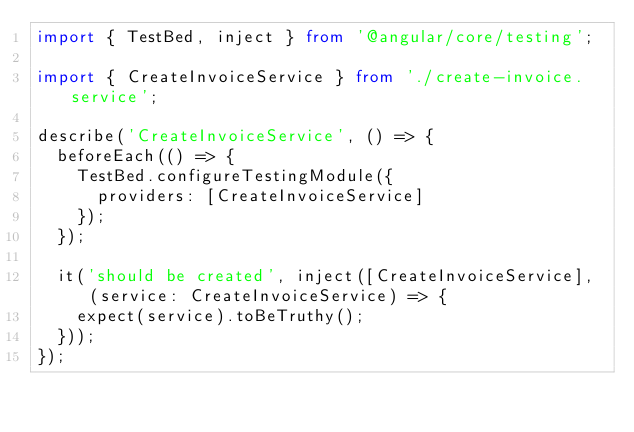Convert code to text. <code><loc_0><loc_0><loc_500><loc_500><_TypeScript_>import { TestBed, inject } from '@angular/core/testing';

import { CreateInvoiceService } from './create-invoice.service';

describe('CreateInvoiceService', () => {
  beforeEach(() => {
    TestBed.configureTestingModule({
      providers: [CreateInvoiceService]
    });
  });

  it('should be created', inject([CreateInvoiceService], (service: CreateInvoiceService) => {
    expect(service).toBeTruthy();
  }));
});
</code> 